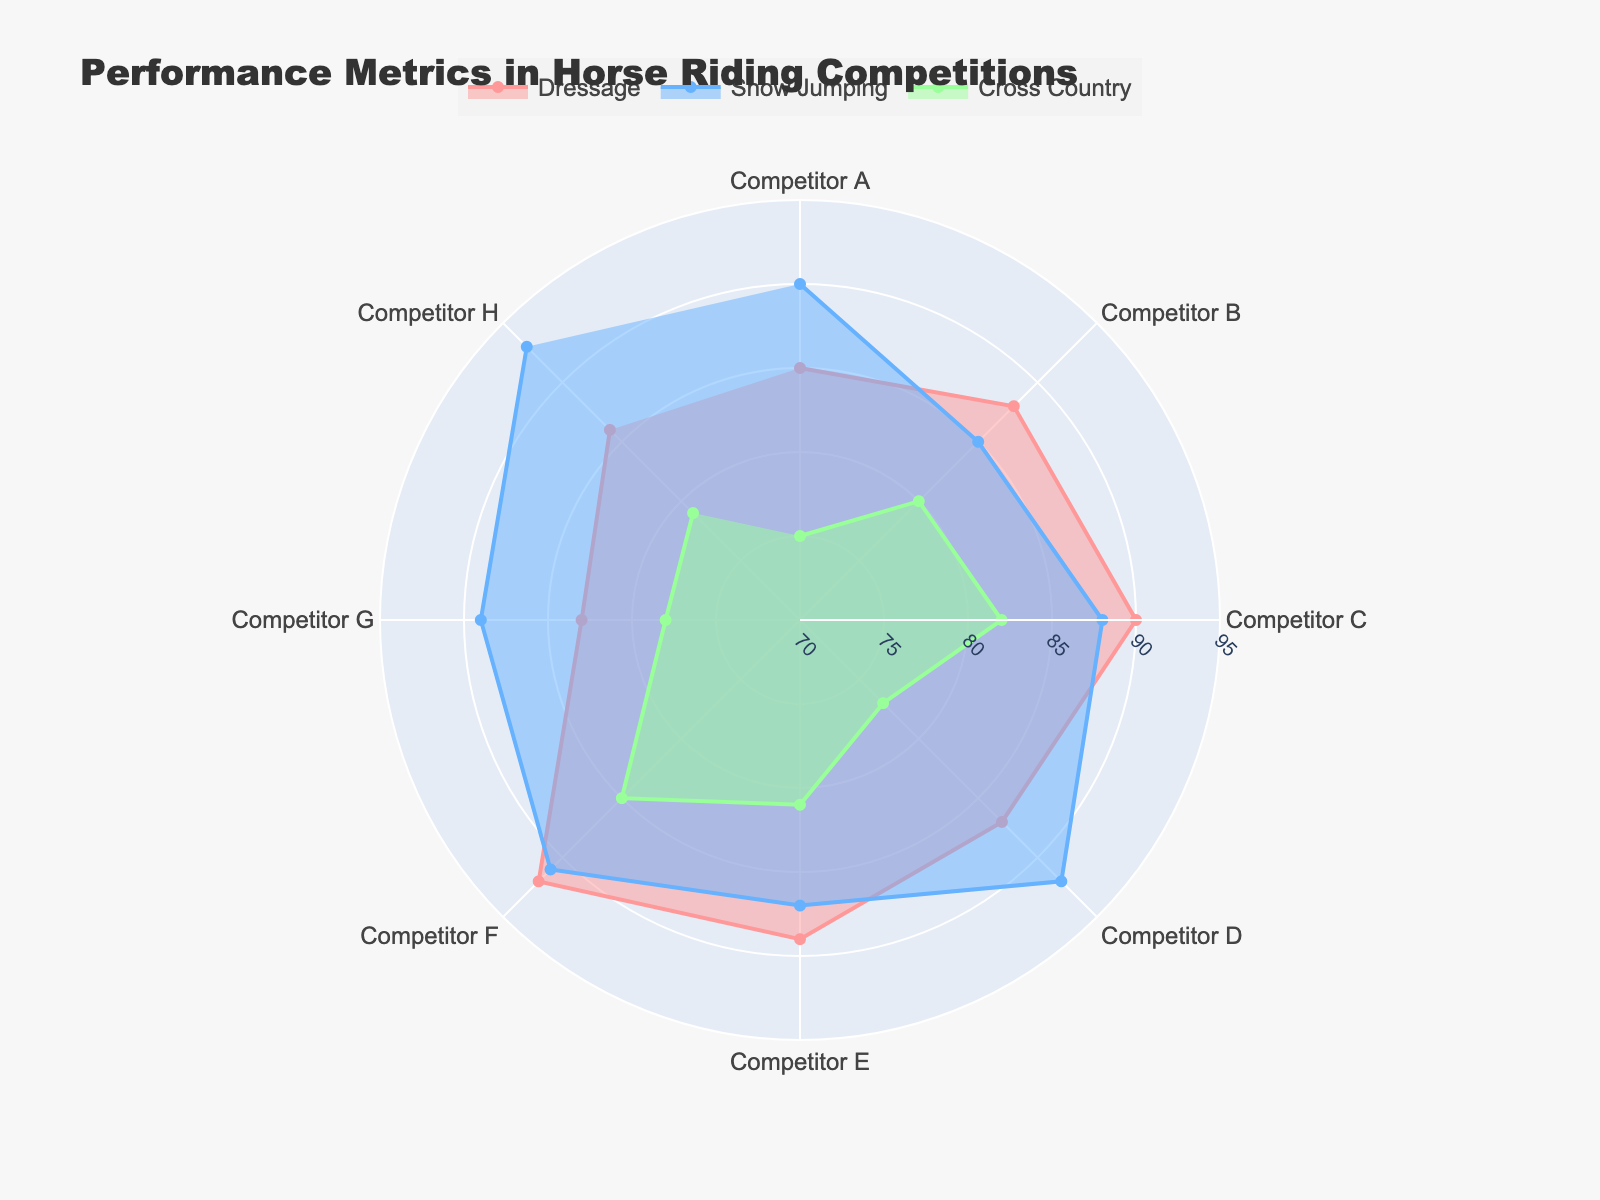what is the title of the chart? The title of the chart is displayed at the top-center of the figure and provides an overview of the data being visualized.
Answer: Performance Metrics in Horse Riding Competitions How many competitors are included in the competition data? The number of competitors can be counted directly from the theta labels around the circular chart.
Answer: 8 Which event type had the highest performance score from Competitor D? By comparing the radial distances for Competitor D across the three event types, the event with the longest radial line is the highest score.
Answer: Show Jumping What's the average performance score in Dressage for all competitors? Sum up the Dressage scores of all competitors (85+88+90+87+89+92+83+86) and divide by the number of competitors (8).
Answer: (85+88+90+87+89+92+83+86)/8 = 700/8 = 87.5 Which competitor had the lowest score in Cross Country? Compare the radial lines for Cross Country scores and identify the shortest one.
Answer: Competitor A with a score of 75 How does Competitor F's performance in Show Jumping compare to Dressage? Look at the radial distances for Competitor F in Show Jumping and Dressage and determine which is longer.
Answer: Show Jumping is higher (91 vs. 92) Who performed better in Dressage, Competitor B or Competitor G? Compare the radial lines for Competitor B and Competitor G in Dressage and determine which one is longer.
Answer: Competitor B What's the range of Cross Country scores among all competitors? Subtract the lowest Cross Country score from the highest Cross Country score among all competitors.
Answer: 85 - 75 = 10 Which event type shows the maximum variability in competitors' scores? Identify the event type with the largest difference between the highest and lowest scores.
Answer: Cross Country (85 - 75 = 10) Who has the most balanced performance across all three event types? Look for the competitor with the least variation in radial distances across all three event types.
Answer: Competitor E (89, 87, 81) 